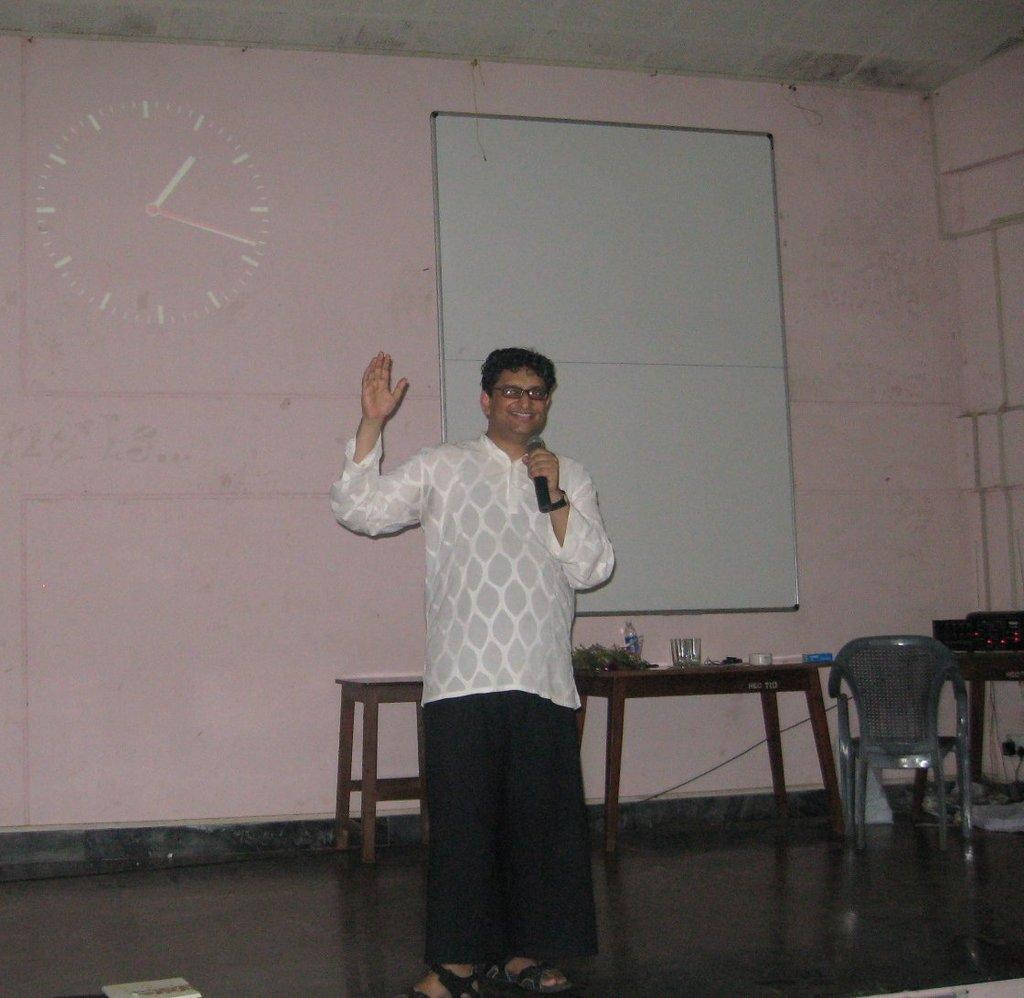Who is the main subject in the image? There is a man in the image. What is the man holding in his hand? The man is holding a mic in his hand. Is the man trying to light a match in the image? There is no match present in the image, and the man is holding a mic, not attempting to light anything. 